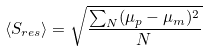Convert formula to latex. <formula><loc_0><loc_0><loc_500><loc_500>\langle S _ { r e s } \rangle = \sqrt { \frac { \sum _ { N } ( \mu _ { p } - \mu _ { m } ) ^ { 2 } } { N } }</formula> 